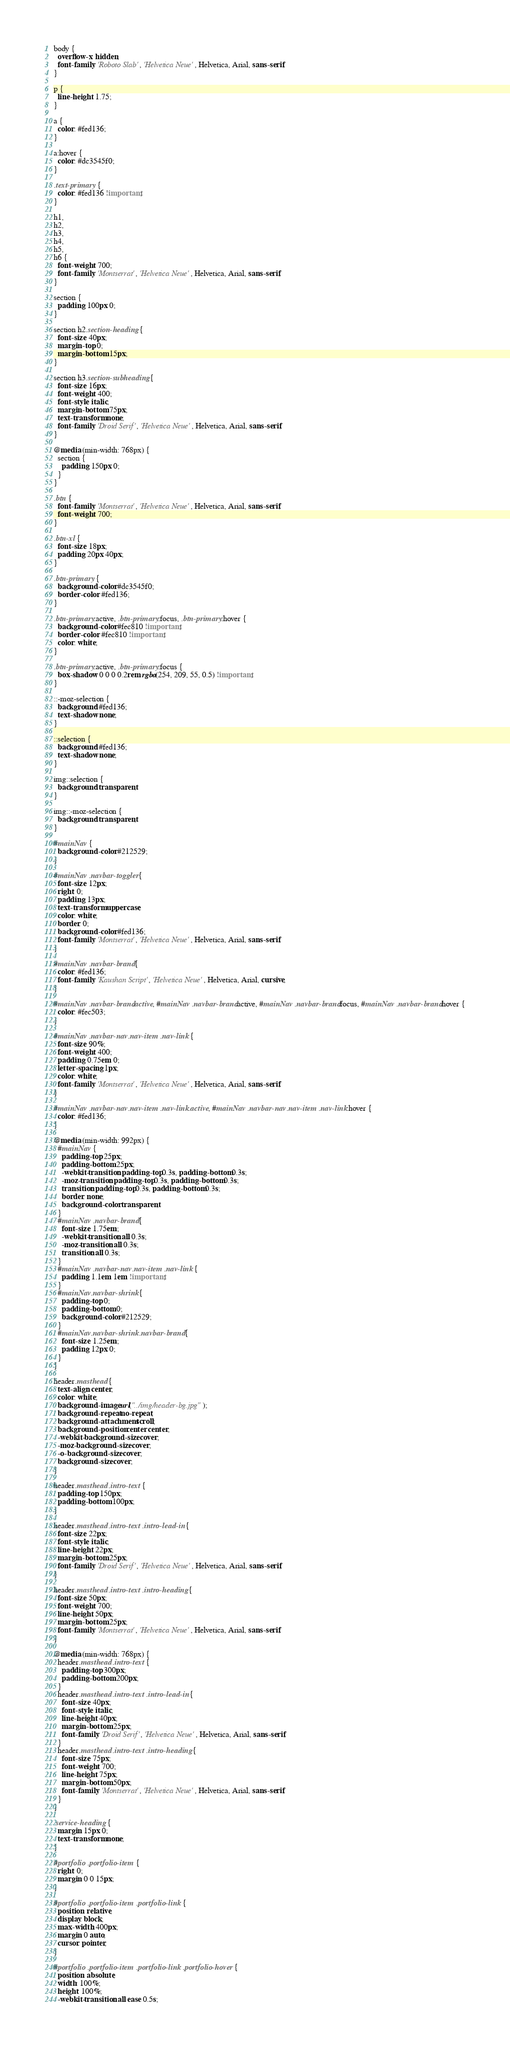Convert code to text. <code><loc_0><loc_0><loc_500><loc_500><_CSS_>body {
  overflow-x: hidden;
  font-family: 'Roboto Slab', 'Helvetica Neue', Helvetica, Arial, sans-serif;
}

p {
  line-height: 1.75;
}

a {
  color: #fed136;
}

a:hover {
  color: #dc3545f0;
}

.text-primary {
  color: #fed136 !important;
}

h1,
h2,
h3,
h4,
h5,
h6 {
  font-weight: 700;
  font-family: 'Montserrat', 'Helvetica Neue', Helvetica, Arial, sans-serif;
}

section {
  padding: 100px 0;
}

section h2.section-heading {
  font-size: 40px;
  margin-top: 0;
  margin-bottom: 15px;
}

section h3.section-subheading {
  font-size: 16px;
  font-weight: 400;
  font-style: italic;
  margin-bottom: 75px;
  text-transform: none;
  font-family: 'Droid Serif', 'Helvetica Neue', Helvetica, Arial, sans-serif;
}

@media (min-width: 768px) {
  section {
    padding: 150px 0;
  }
}

.btn {
  font-family: 'Montserrat', 'Helvetica Neue', Helvetica, Arial, sans-serif;
  font-weight: 700;
}

.btn-xl {
  font-size: 18px;
  padding: 20px 40px;
}

.btn-primary {
  background-color: #dc3545f0;
  border-color: #fed136;
}

.btn-primary:active, .btn-primary:focus, .btn-primary:hover {
  background-color: #fec810 !important;
  border-color: #fec810 !important;
  color: white;
}

.btn-primary:active, .btn-primary:focus {
  box-shadow: 0 0 0 0.2rem rgba(254, 209, 55, 0.5) !important;
}

::-moz-selection {
  background: #fed136;
  text-shadow: none;
}

::selection {
  background: #fed136;
  text-shadow: none;
}

img::selection {
  background: transparent;
}

img::-moz-selection {
  background: transparent;
}

#mainNav {
  background-color: #212529;
}

#mainNav .navbar-toggler {
  font-size: 12px;
  right: 0;
  padding: 13px;
  text-transform: uppercase;
  color: white;
  border: 0;
  background-color: #fed136;
  font-family: 'Montserrat', 'Helvetica Neue', Helvetica, Arial, sans-serif;
}

#mainNav .navbar-brand {
  color: #fed136;
  font-family: 'Kaushan Script', 'Helvetica Neue', Helvetica, Arial, cursive;
}

#mainNav .navbar-brand.active, #mainNav .navbar-brand:active, #mainNav .navbar-brand:focus, #mainNav .navbar-brand:hover {
  color: #fec503;
}

#mainNav .navbar-nav .nav-item .nav-link {
  font-size: 90%;
  font-weight: 400;
  padding: 0.75em 0;
  letter-spacing: 1px;
  color: white;
  font-family: 'Montserrat', 'Helvetica Neue', Helvetica, Arial, sans-serif;
}

#mainNav .navbar-nav .nav-item .nav-link.active, #mainNav .navbar-nav .nav-item .nav-link:hover {
  color: #fed136;
}

@media (min-width: 992px) {
  #mainNav {
    padding-top: 25px;
    padding-bottom: 25px;
    -webkit-transition: padding-top 0.3s, padding-bottom 0.3s;
    -moz-transition: padding-top 0.3s, padding-bottom 0.3s;
    transition: padding-top 0.3s, padding-bottom 0.3s;
    border: none;
    background-color: transparent;
  }
  #mainNav .navbar-brand {
    font-size: 1.75em;
    -webkit-transition: all 0.3s;
    -moz-transition: all 0.3s;
    transition: all 0.3s;
  }
  #mainNav .navbar-nav .nav-item .nav-link {
    padding: 1.1em 1em !important;
  }
  #mainNav.navbar-shrink {
    padding-top: 0;
    padding-bottom: 0;
    background-color: #212529;
  }
  #mainNav.navbar-shrink .navbar-brand {
    font-size: 1.25em;
    padding: 12px 0;
  }
}

header.masthead {
  text-align: center;
  color: white;
  background-image: url("../img/header-bg.jpg");
  background-repeat: no-repeat;
  background-attachment: scroll;
  background-position: center center;
  -webkit-background-size: cover;
  -moz-background-size: cover;
  -o-background-size: cover;
  background-size: cover;
}

header.masthead .intro-text {
  padding-top: 150px;
  padding-bottom: 100px;
}

header.masthead .intro-text .intro-lead-in {
  font-size: 22px;
  font-style: italic;
  line-height: 22px;
  margin-bottom: 25px;
  font-family: 'Droid Serif', 'Helvetica Neue', Helvetica, Arial, sans-serif;
}

header.masthead .intro-text .intro-heading {
  font-size: 50px;
  font-weight: 700;
  line-height: 50px;
  margin-bottom: 25px;
  font-family: 'Montserrat', 'Helvetica Neue', Helvetica, Arial, sans-serif;
}

@media (min-width: 768px) {
  header.masthead .intro-text {
    padding-top: 300px;
    padding-bottom: 200px;
  }
  header.masthead .intro-text .intro-lead-in {
    font-size: 40px;
    font-style: italic;
    line-height: 40px;
    margin-bottom: 25px;
    font-family: 'Droid Serif', 'Helvetica Neue', Helvetica, Arial, sans-serif;
  }
  header.masthead .intro-text .intro-heading {
    font-size: 75px;
    font-weight: 700;
    line-height: 75px;
    margin-bottom: 50px;
    font-family: 'Montserrat', 'Helvetica Neue', Helvetica, Arial, sans-serif;
  }
}

.service-heading {
  margin: 15px 0;
  text-transform: none;
}

#portfolio .portfolio-item {
  right: 0;
  margin: 0 0 15px;
}

#portfolio .portfolio-item .portfolio-link {
  position: relative;
  display: block;
  max-width: 400px;
  margin: 0 auto;
  cursor: pointer;
}

#portfolio .portfolio-item .portfolio-link .portfolio-hover {
  position: absolute;
  width: 100%;
  height: 100%;
  -webkit-transition: all ease 0.5s;</code> 